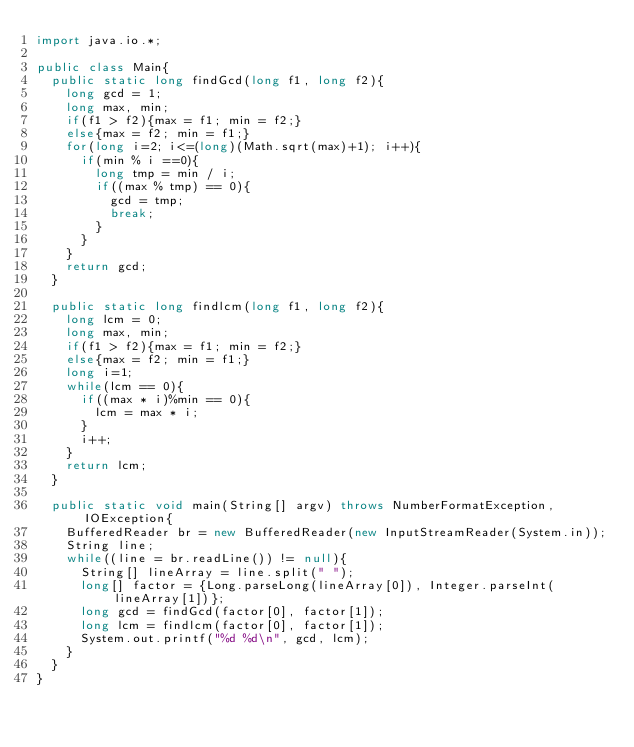Convert code to text. <code><loc_0><loc_0><loc_500><loc_500><_Java_>import java.io.*;

public class Main{
	public static long findGcd(long f1, long f2){
		long gcd = 1;
		long max, min;
		if(f1 > f2){max = f1; min = f2;}
		else{max = f2; min = f1;}
		for(long i=2; i<=(long)(Math.sqrt(max)+1); i++){
			if(min % i ==0){
				long tmp = min / i;
				if((max % tmp) == 0){
					gcd = tmp;
					break;
				}
			}
		}
		return gcd;
	}
	
	public static long findlcm(long f1, long f2){
		long lcm = 0;
		long max, min;
		if(f1 > f2){max = f1; min = f2;}
		else{max = f2; min = f1;}
		long i=1;
		while(lcm == 0){
			if((max * i)%min == 0){
				lcm = max * i;
			}
			i++;
		}
		return lcm;
	}
	
	public static void main(String[] argv) throws NumberFormatException, IOException{
		BufferedReader br = new BufferedReader(new InputStreamReader(System.in));
		String line;
		while((line = br.readLine()) != null){
			String[] lineArray = line.split(" ");
			long[] factor = {Long.parseLong(lineArray[0]), Integer.parseInt(lineArray[1])};
			long gcd = findGcd(factor[0], factor[1]);
			long lcm = findlcm(factor[0], factor[1]);
			System.out.printf("%d %d\n", gcd, lcm);
		}
	}
}</code> 